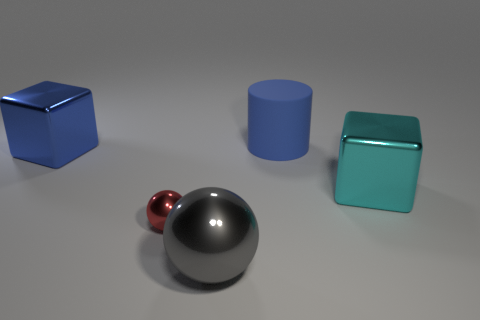Is there any other thing that has the same size as the red thing?
Offer a terse response. No. What is the size of the cube left of the object behind the big metal object that is to the left of the tiny metal sphere?
Offer a very short reply. Large. What number of red things are either tiny things or cubes?
Your answer should be very brief. 1. There is a blue thing to the left of the large blue thing that is behind the blue shiny block; what is its shape?
Offer a terse response. Cube. Is the size of the ball that is on the right side of the red metallic sphere the same as the red metal sphere that is in front of the big blue rubber thing?
Provide a succinct answer. No. Are there any other cyan objects made of the same material as the cyan thing?
Your response must be concise. No. There is a cube that is the same color as the large rubber cylinder; what is its size?
Provide a succinct answer. Large. Is there a object behind the big thing to the right of the large thing behind the blue shiny object?
Your answer should be compact. Yes. Are there any spheres right of the big gray shiny object?
Provide a short and direct response. No. There is a large cube right of the blue shiny cube; what number of large metal things are right of it?
Your response must be concise. 0. 